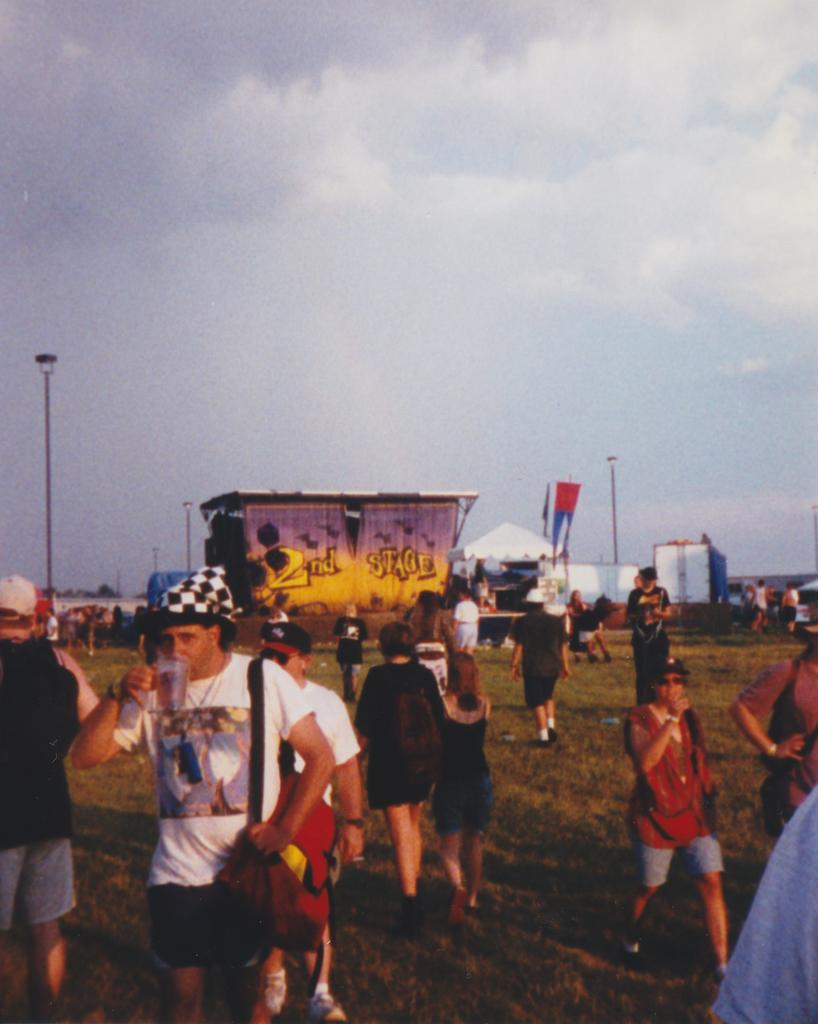Who or what is present in the image? There are people in the image. What are the people doing in the image? The people are holding things. What type of structures can be seen in the image? There are sheds in the image. Are there any other objects or features visible in the image? Yes, there are poles in the image. What type of bread can be seen on the foot of the person in the image? There is no bread or foot visible in the image; it only shows people holding things, sheds, and poles. 